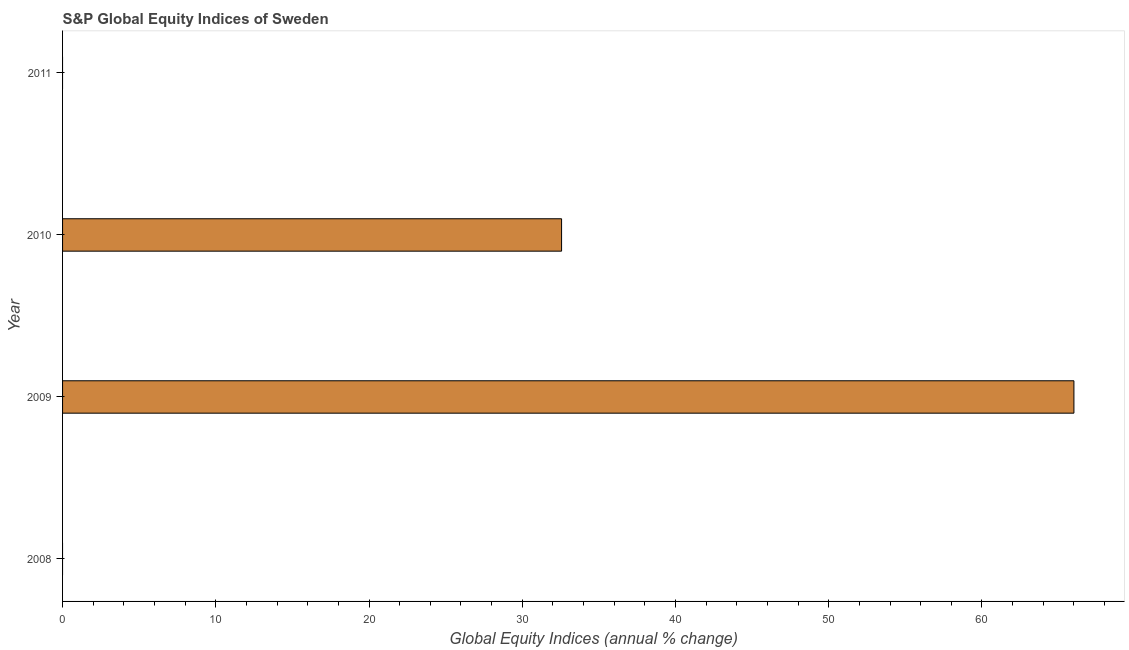Does the graph contain any zero values?
Your answer should be compact. Yes. Does the graph contain grids?
Keep it short and to the point. No. What is the title of the graph?
Your answer should be very brief. S&P Global Equity Indices of Sweden. What is the label or title of the X-axis?
Keep it short and to the point. Global Equity Indices (annual % change). What is the label or title of the Y-axis?
Keep it short and to the point. Year. What is the s&p global equity indices in 2008?
Your answer should be very brief. 0. Across all years, what is the maximum s&p global equity indices?
Give a very brief answer. 66. What is the sum of the s&p global equity indices?
Ensure brevity in your answer.  98.56. What is the difference between the s&p global equity indices in 2009 and 2010?
Your response must be concise. 33.44. What is the average s&p global equity indices per year?
Offer a terse response. 24.64. What is the median s&p global equity indices?
Ensure brevity in your answer.  16.28. In how many years, is the s&p global equity indices greater than 16 %?
Your answer should be compact. 2. Is the sum of the s&p global equity indices in 2009 and 2010 greater than the maximum s&p global equity indices across all years?
Offer a very short reply. Yes. How many bars are there?
Offer a very short reply. 2. How many years are there in the graph?
Give a very brief answer. 4. What is the Global Equity Indices (annual % change) of 2009?
Keep it short and to the point. 66. What is the Global Equity Indices (annual % change) of 2010?
Your answer should be compact. 32.56. What is the Global Equity Indices (annual % change) in 2011?
Your response must be concise. 0. What is the difference between the Global Equity Indices (annual % change) in 2009 and 2010?
Give a very brief answer. 33.44. What is the ratio of the Global Equity Indices (annual % change) in 2009 to that in 2010?
Provide a succinct answer. 2.03. 